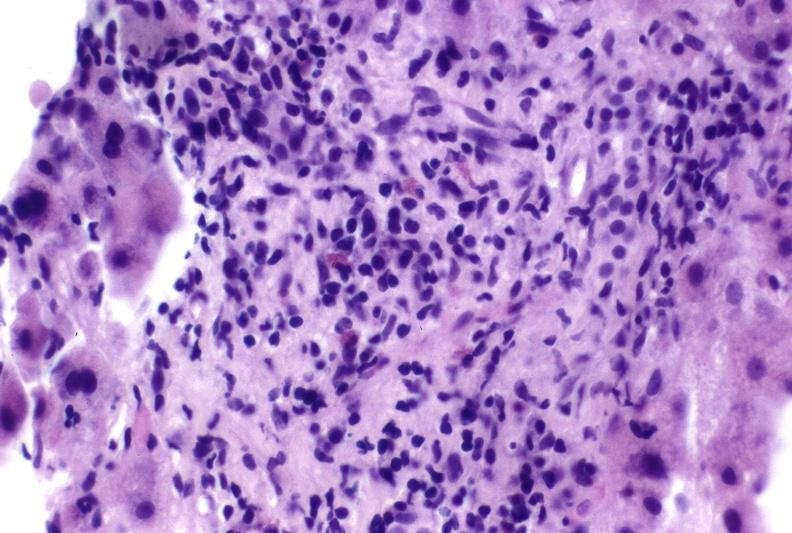does this image show autoimmune hepatitis?
Answer the question using a single word or phrase. Yes 